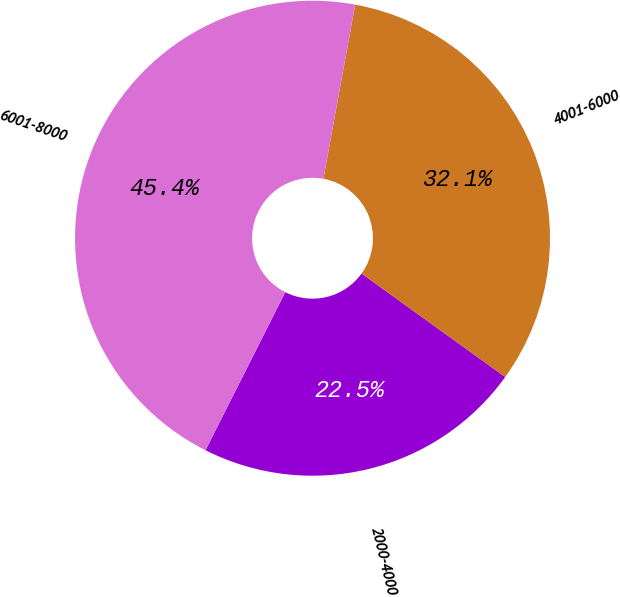Convert chart to OTSL. <chart><loc_0><loc_0><loc_500><loc_500><pie_chart><fcel>2000-4000<fcel>4001-6000<fcel>6001-8000<nl><fcel>22.51%<fcel>32.06%<fcel>45.44%<nl></chart> 